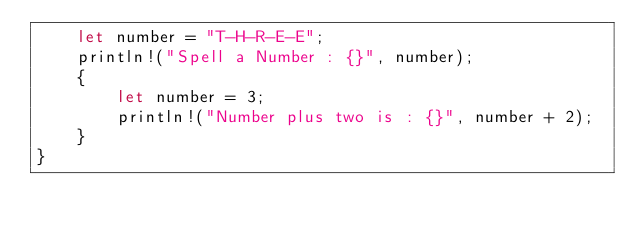Convert code to text. <code><loc_0><loc_0><loc_500><loc_500><_Rust_>    let number = "T-H-R-E-E";
    println!("Spell a Number : {}", number);
    {
        let number = 3;
        println!("Number plus two is : {}", number + 2);
    }
}
</code> 